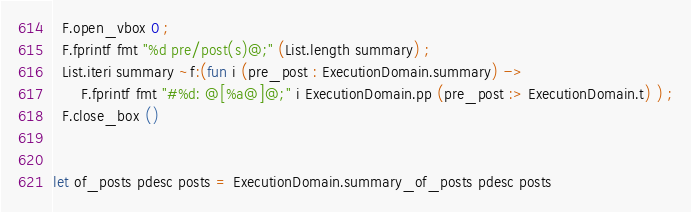<code> <loc_0><loc_0><loc_500><loc_500><_OCaml_>  F.open_vbox 0 ;
  F.fprintf fmt "%d pre/post(s)@;" (List.length summary) ;
  List.iteri summary ~f:(fun i (pre_post : ExecutionDomain.summary) ->
      F.fprintf fmt "#%d: @[%a@]@;" i ExecutionDomain.pp (pre_post :> ExecutionDomain.t) ) ;
  F.close_box ()


let of_posts pdesc posts = ExecutionDomain.summary_of_posts pdesc posts
</code> 